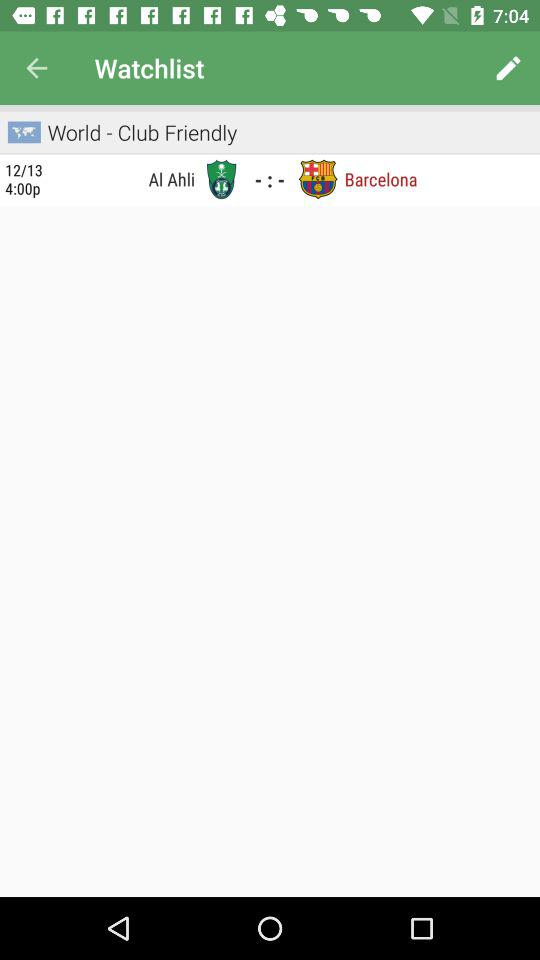What is the given time? The given time is 4:00 pm. 